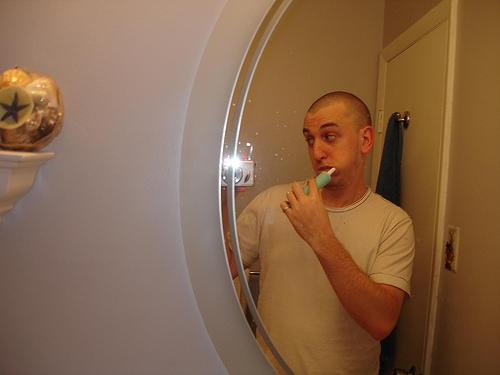Question: where was the picture taken?
Choices:
A. In a bathroom.
B. In a den.
C. In a bedroom.
D. In a kitchen.
Answer with the letter. Answer: A Question: what gender is the person?
Choices:
A. Female.
B. Intersex.
C. Male.
D. Bigender.
Answer with the letter. Answer: C Question: what is the man holding in his left hand?
Choices:
A. A razor.
B. A washcloth.
C. Deodorant.
D. A toothbrush.
Answer with the letter. Answer: D Question: what color is the man's t-shirt?
Choices:
A. White.
B. Red.
C. Blue.
D. Peach.
Answer with the letter. Answer: A 